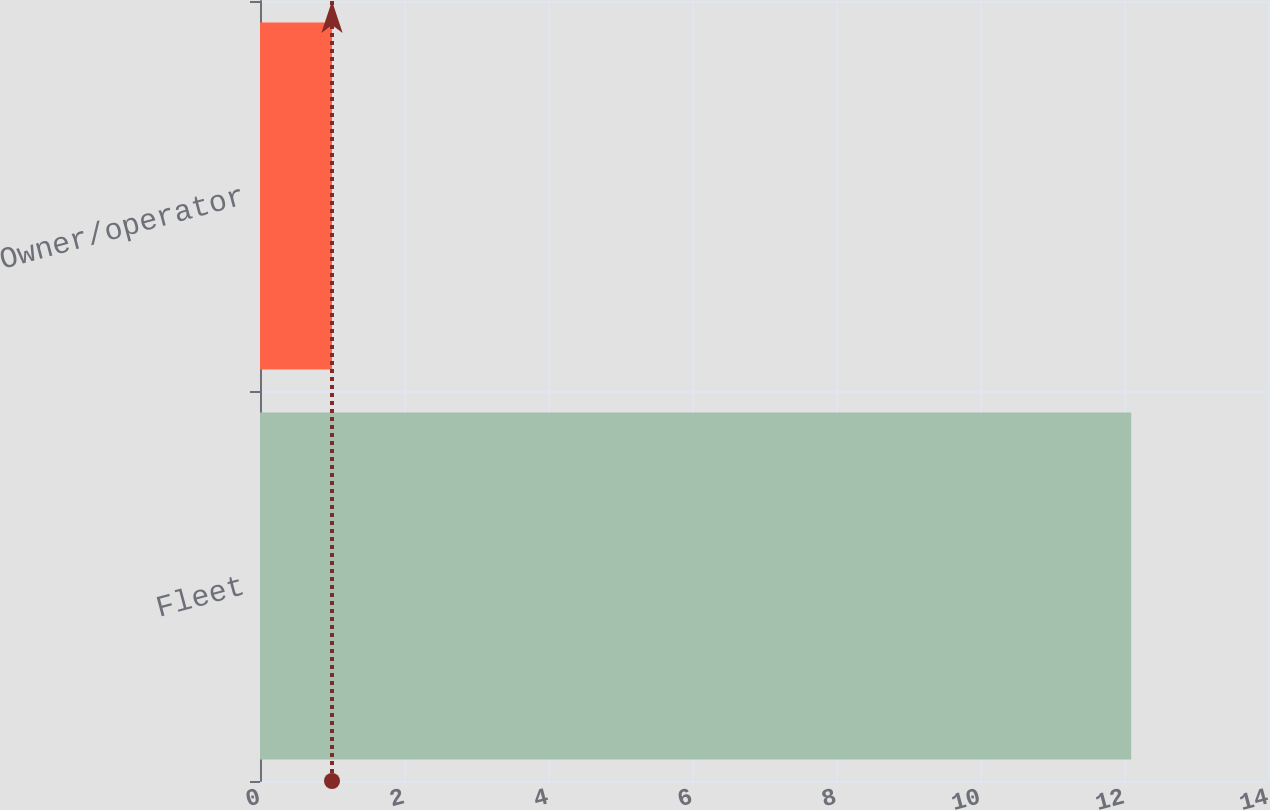<chart> <loc_0><loc_0><loc_500><loc_500><bar_chart><fcel>Fleet<fcel>Owner/operator<nl><fcel>12.1<fcel>1<nl></chart> 